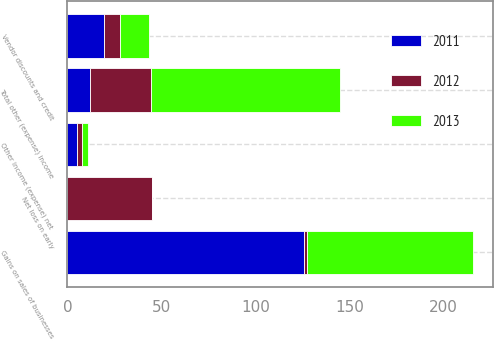Convert chart. <chart><loc_0><loc_0><loc_500><loc_500><stacked_bar_chart><ecel><fcel>Net loss on early<fcel>Gains on sales of businesses<fcel>Vendor discounts and credit<fcel>Other income (expense) net<fcel>Total other (expense) income<nl><fcel>2012<fcel>45.2<fcel>1.5<fcel>8.6<fcel>2.8<fcel>32.3<nl><fcel>2013<fcel>0<fcel>88.2<fcel>15.3<fcel>3<fcel>100.5<nl><fcel>2011<fcel>0<fcel>125.9<fcel>19.4<fcel>4.9<fcel>11.95<nl></chart> 